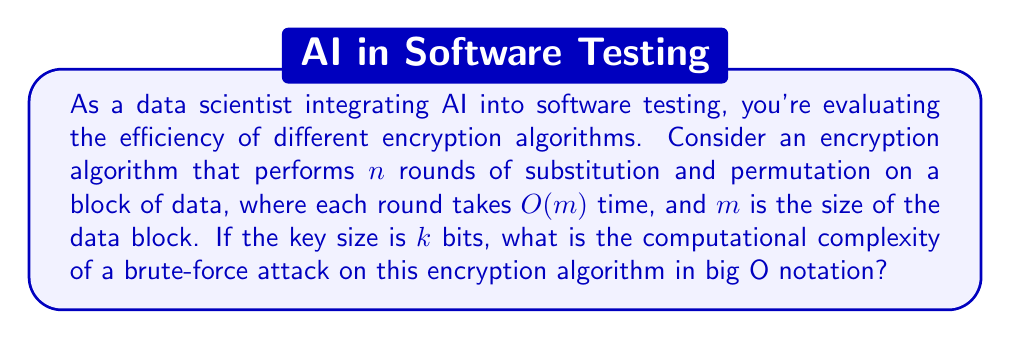Give your solution to this math problem. To determine the computational complexity of a brute-force attack, we need to consider the following steps:

1) In a brute-force attack, we need to try all possible keys. With a key size of $k$ bits, there are $2^k$ possible keys.

2) For each key, we need to perform the encryption algorithm:
   - The algorithm performs $n$ rounds
   - Each round takes $O(m)$ time
   - So, the total time for one encryption is $O(nm)$

3) We need to perform this encryption for each possible key. Therefore, the total complexity is:

   $$ O(2^k \cdot nm) $$

4) In big O notation, we typically express complexity in terms of the input parameters. Here, our input parameters are $k$ (key size), $n$ (number of rounds), and $m$ (block size).

5) Since $2^k$ grows much faster than $n$ or $m$ as $k$ increases, it dominates the expression. Therefore, we can simplify the complexity to:

   $$ O(2^k) $$

This represents the exponential growth of the computational complexity with respect to the key size, which is characteristic of brute-force attacks on encryption algorithms.
Answer: $O(2^k)$ 